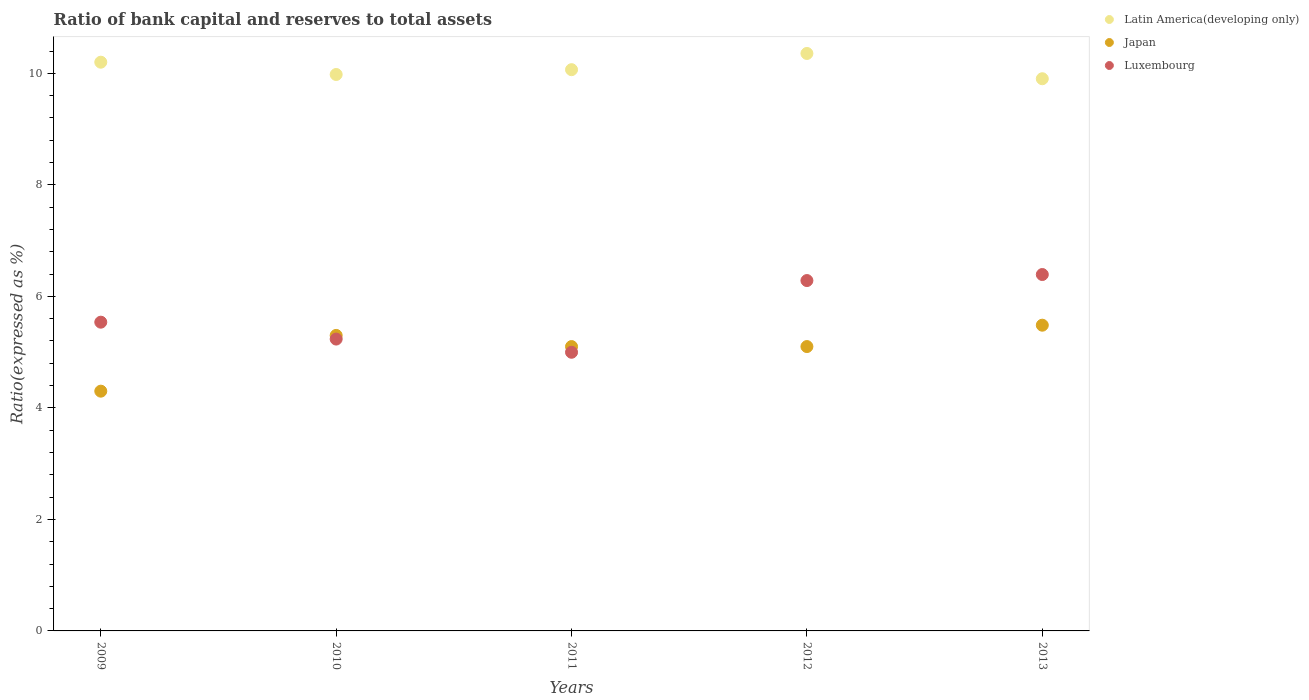What is the ratio of bank capital and reserves to total assets in Latin America(developing only) in 2012?
Offer a very short reply. 10.36. Across all years, what is the maximum ratio of bank capital and reserves to total assets in Japan?
Offer a very short reply. 5.48. Across all years, what is the minimum ratio of bank capital and reserves to total assets in Latin America(developing only)?
Offer a very short reply. 9.9. In which year was the ratio of bank capital and reserves to total assets in Latin America(developing only) maximum?
Provide a short and direct response. 2012. What is the total ratio of bank capital and reserves to total assets in Latin America(developing only) in the graph?
Give a very brief answer. 50.51. What is the difference between the ratio of bank capital and reserves to total assets in Latin America(developing only) in 2011 and that in 2013?
Make the answer very short. 0.16. What is the difference between the ratio of bank capital and reserves to total assets in Latin America(developing only) in 2010 and the ratio of bank capital and reserves to total assets in Luxembourg in 2009?
Your answer should be compact. 4.44. What is the average ratio of bank capital and reserves to total assets in Latin America(developing only) per year?
Keep it short and to the point. 10.1. In the year 2012, what is the difference between the ratio of bank capital and reserves to total assets in Luxembourg and ratio of bank capital and reserves to total assets in Latin America(developing only)?
Your answer should be compact. -4.07. In how many years, is the ratio of bank capital and reserves to total assets in Latin America(developing only) greater than 7.6 %?
Give a very brief answer. 5. Is the ratio of bank capital and reserves to total assets in Luxembourg in 2011 less than that in 2013?
Offer a very short reply. Yes. Is the difference between the ratio of bank capital and reserves to total assets in Luxembourg in 2009 and 2012 greater than the difference between the ratio of bank capital and reserves to total assets in Latin America(developing only) in 2009 and 2012?
Your response must be concise. No. What is the difference between the highest and the second highest ratio of bank capital and reserves to total assets in Latin America(developing only)?
Your response must be concise. 0.16. What is the difference between the highest and the lowest ratio of bank capital and reserves to total assets in Japan?
Offer a terse response. 1.18. In how many years, is the ratio of bank capital and reserves to total assets in Luxembourg greater than the average ratio of bank capital and reserves to total assets in Luxembourg taken over all years?
Keep it short and to the point. 2. Is it the case that in every year, the sum of the ratio of bank capital and reserves to total assets in Latin America(developing only) and ratio of bank capital and reserves to total assets in Japan  is greater than the ratio of bank capital and reserves to total assets in Luxembourg?
Make the answer very short. Yes. Does the ratio of bank capital and reserves to total assets in Latin America(developing only) monotonically increase over the years?
Keep it short and to the point. No. Is the ratio of bank capital and reserves to total assets in Japan strictly greater than the ratio of bank capital and reserves to total assets in Luxembourg over the years?
Your answer should be compact. No. How many dotlines are there?
Make the answer very short. 3. How many years are there in the graph?
Provide a succinct answer. 5. Are the values on the major ticks of Y-axis written in scientific E-notation?
Your response must be concise. No. Does the graph contain any zero values?
Offer a terse response. No. How are the legend labels stacked?
Offer a terse response. Vertical. What is the title of the graph?
Offer a terse response. Ratio of bank capital and reserves to total assets. What is the label or title of the Y-axis?
Your response must be concise. Ratio(expressed as %). What is the Ratio(expressed as %) in Japan in 2009?
Offer a very short reply. 4.3. What is the Ratio(expressed as %) in Luxembourg in 2009?
Provide a succinct answer. 5.54. What is the Ratio(expressed as %) in Latin America(developing only) in 2010?
Your response must be concise. 9.98. What is the Ratio(expressed as %) of Japan in 2010?
Keep it short and to the point. 5.3. What is the Ratio(expressed as %) of Luxembourg in 2010?
Provide a short and direct response. 5.23. What is the Ratio(expressed as %) in Latin America(developing only) in 2011?
Your answer should be very brief. 10.07. What is the Ratio(expressed as %) in Japan in 2011?
Your answer should be very brief. 5.1. What is the Ratio(expressed as %) in Luxembourg in 2011?
Make the answer very short. 5. What is the Ratio(expressed as %) in Latin America(developing only) in 2012?
Your answer should be very brief. 10.36. What is the Ratio(expressed as %) in Luxembourg in 2012?
Offer a very short reply. 6.28. What is the Ratio(expressed as %) of Latin America(developing only) in 2013?
Provide a succinct answer. 9.9. What is the Ratio(expressed as %) in Japan in 2013?
Your answer should be compact. 5.48. What is the Ratio(expressed as %) in Luxembourg in 2013?
Keep it short and to the point. 6.39. Across all years, what is the maximum Ratio(expressed as %) in Latin America(developing only)?
Offer a very short reply. 10.36. Across all years, what is the maximum Ratio(expressed as %) in Japan?
Provide a short and direct response. 5.48. Across all years, what is the maximum Ratio(expressed as %) of Luxembourg?
Offer a terse response. 6.39. Across all years, what is the minimum Ratio(expressed as %) of Latin America(developing only)?
Ensure brevity in your answer.  9.9. Across all years, what is the minimum Ratio(expressed as %) in Japan?
Your response must be concise. 4.3. Across all years, what is the minimum Ratio(expressed as %) in Luxembourg?
Make the answer very short. 5. What is the total Ratio(expressed as %) of Latin America(developing only) in the graph?
Your answer should be compact. 50.51. What is the total Ratio(expressed as %) of Japan in the graph?
Your answer should be very brief. 25.28. What is the total Ratio(expressed as %) in Luxembourg in the graph?
Offer a terse response. 28.45. What is the difference between the Ratio(expressed as %) in Latin America(developing only) in 2009 and that in 2010?
Provide a succinct answer. 0.22. What is the difference between the Ratio(expressed as %) in Japan in 2009 and that in 2010?
Offer a terse response. -1. What is the difference between the Ratio(expressed as %) of Luxembourg in 2009 and that in 2010?
Your answer should be compact. 0.3. What is the difference between the Ratio(expressed as %) of Latin America(developing only) in 2009 and that in 2011?
Your response must be concise. 0.13. What is the difference between the Ratio(expressed as %) of Japan in 2009 and that in 2011?
Offer a very short reply. -0.8. What is the difference between the Ratio(expressed as %) in Luxembourg in 2009 and that in 2011?
Offer a terse response. 0.54. What is the difference between the Ratio(expressed as %) in Latin America(developing only) in 2009 and that in 2012?
Your answer should be very brief. -0.16. What is the difference between the Ratio(expressed as %) of Japan in 2009 and that in 2012?
Provide a succinct answer. -0.8. What is the difference between the Ratio(expressed as %) of Luxembourg in 2009 and that in 2012?
Keep it short and to the point. -0.75. What is the difference between the Ratio(expressed as %) of Latin America(developing only) in 2009 and that in 2013?
Provide a short and direct response. 0.3. What is the difference between the Ratio(expressed as %) of Japan in 2009 and that in 2013?
Keep it short and to the point. -1.18. What is the difference between the Ratio(expressed as %) of Luxembourg in 2009 and that in 2013?
Keep it short and to the point. -0.85. What is the difference between the Ratio(expressed as %) of Latin America(developing only) in 2010 and that in 2011?
Keep it short and to the point. -0.09. What is the difference between the Ratio(expressed as %) of Luxembourg in 2010 and that in 2011?
Offer a terse response. 0.24. What is the difference between the Ratio(expressed as %) of Latin America(developing only) in 2010 and that in 2012?
Your response must be concise. -0.38. What is the difference between the Ratio(expressed as %) in Luxembourg in 2010 and that in 2012?
Keep it short and to the point. -1.05. What is the difference between the Ratio(expressed as %) in Latin America(developing only) in 2010 and that in 2013?
Give a very brief answer. 0.08. What is the difference between the Ratio(expressed as %) in Japan in 2010 and that in 2013?
Make the answer very short. -0.18. What is the difference between the Ratio(expressed as %) of Luxembourg in 2010 and that in 2013?
Provide a short and direct response. -1.16. What is the difference between the Ratio(expressed as %) in Latin America(developing only) in 2011 and that in 2012?
Your answer should be compact. -0.29. What is the difference between the Ratio(expressed as %) in Luxembourg in 2011 and that in 2012?
Ensure brevity in your answer.  -1.29. What is the difference between the Ratio(expressed as %) in Latin America(developing only) in 2011 and that in 2013?
Provide a short and direct response. 0.16. What is the difference between the Ratio(expressed as %) of Japan in 2011 and that in 2013?
Your answer should be very brief. -0.38. What is the difference between the Ratio(expressed as %) of Luxembourg in 2011 and that in 2013?
Make the answer very short. -1.39. What is the difference between the Ratio(expressed as %) in Latin America(developing only) in 2012 and that in 2013?
Give a very brief answer. 0.45. What is the difference between the Ratio(expressed as %) in Japan in 2012 and that in 2013?
Offer a terse response. -0.38. What is the difference between the Ratio(expressed as %) of Luxembourg in 2012 and that in 2013?
Your response must be concise. -0.11. What is the difference between the Ratio(expressed as %) of Latin America(developing only) in 2009 and the Ratio(expressed as %) of Luxembourg in 2010?
Give a very brief answer. 4.97. What is the difference between the Ratio(expressed as %) of Japan in 2009 and the Ratio(expressed as %) of Luxembourg in 2010?
Offer a very short reply. -0.93. What is the difference between the Ratio(expressed as %) of Latin America(developing only) in 2009 and the Ratio(expressed as %) of Luxembourg in 2011?
Ensure brevity in your answer.  5.2. What is the difference between the Ratio(expressed as %) in Japan in 2009 and the Ratio(expressed as %) in Luxembourg in 2011?
Offer a very short reply. -0.7. What is the difference between the Ratio(expressed as %) of Latin America(developing only) in 2009 and the Ratio(expressed as %) of Japan in 2012?
Give a very brief answer. 5.1. What is the difference between the Ratio(expressed as %) in Latin America(developing only) in 2009 and the Ratio(expressed as %) in Luxembourg in 2012?
Your response must be concise. 3.92. What is the difference between the Ratio(expressed as %) of Japan in 2009 and the Ratio(expressed as %) of Luxembourg in 2012?
Ensure brevity in your answer.  -1.98. What is the difference between the Ratio(expressed as %) of Latin America(developing only) in 2009 and the Ratio(expressed as %) of Japan in 2013?
Ensure brevity in your answer.  4.72. What is the difference between the Ratio(expressed as %) of Latin America(developing only) in 2009 and the Ratio(expressed as %) of Luxembourg in 2013?
Ensure brevity in your answer.  3.81. What is the difference between the Ratio(expressed as %) of Japan in 2009 and the Ratio(expressed as %) of Luxembourg in 2013?
Your response must be concise. -2.09. What is the difference between the Ratio(expressed as %) of Latin America(developing only) in 2010 and the Ratio(expressed as %) of Japan in 2011?
Your response must be concise. 4.88. What is the difference between the Ratio(expressed as %) in Latin America(developing only) in 2010 and the Ratio(expressed as %) in Luxembourg in 2011?
Your response must be concise. 4.98. What is the difference between the Ratio(expressed as %) in Japan in 2010 and the Ratio(expressed as %) in Luxembourg in 2011?
Give a very brief answer. 0.3. What is the difference between the Ratio(expressed as %) in Latin America(developing only) in 2010 and the Ratio(expressed as %) in Japan in 2012?
Ensure brevity in your answer.  4.88. What is the difference between the Ratio(expressed as %) of Latin America(developing only) in 2010 and the Ratio(expressed as %) of Luxembourg in 2012?
Make the answer very short. 3.7. What is the difference between the Ratio(expressed as %) of Japan in 2010 and the Ratio(expressed as %) of Luxembourg in 2012?
Provide a succinct answer. -0.98. What is the difference between the Ratio(expressed as %) of Latin America(developing only) in 2010 and the Ratio(expressed as %) of Japan in 2013?
Give a very brief answer. 4.5. What is the difference between the Ratio(expressed as %) in Latin America(developing only) in 2010 and the Ratio(expressed as %) in Luxembourg in 2013?
Ensure brevity in your answer.  3.59. What is the difference between the Ratio(expressed as %) in Japan in 2010 and the Ratio(expressed as %) in Luxembourg in 2013?
Provide a short and direct response. -1.09. What is the difference between the Ratio(expressed as %) of Latin America(developing only) in 2011 and the Ratio(expressed as %) of Japan in 2012?
Your answer should be compact. 4.97. What is the difference between the Ratio(expressed as %) of Latin America(developing only) in 2011 and the Ratio(expressed as %) of Luxembourg in 2012?
Provide a succinct answer. 3.78. What is the difference between the Ratio(expressed as %) in Japan in 2011 and the Ratio(expressed as %) in Luxembourg in 2012?
Provide a short and direct response. -1.18. What is the difference between the Ratio(expressed as %) in Latin America(developing only) in 2011 and the Ratio(expressed as %) in Japan in 2013?
Your answer should be compact. 4.58. What is the difference between the Ratio(expressed as %) in Latin America(developing only) in 2011 and the Ratio(expressed as %) in Luxembourg in 2013?
Your answer should be very brief. 3.67. What is the difference between the Ratio(expressed as %) in Japan in 2011 and the Ratio(expressed as %) in Luxembourg in 2013?
Make the answer very short. -1.29. What is the difference between the Ratio(expressed as %) in Latin America(developing only) in 2012 and the Ratio(expressed as %) in Japan in 2013?
Your response must be concise. 4.87. What is the difference between the Ratio(expressed as %) of Latin America(developing only) in 2012 and the Ratio(expressed as %) of Luxembourg in 2013?
Your answer should be compact. 3.96. What is the difference between the Ratio(expressed as %) of Japan in 2012 and the Ratio(expressed as %) of Luxembourg in 2013?
Give a very brief answer. -1.29. What is the average Ratio(expressed as %) of Latin America(developing only) per year?
Your answer should be very brief. 10.1. What is the average Ratio(expressed as %) of Japan per year?
Offer a terse response. 5.06. What is the average Ratio(expressed as %) of Luxembourg per year?
Offer a very short reply. 5.69. In the year 2009, what is the difference between the Ratio(expressed as %) of Latin America(developing only) and Ratio(expressed as %) of Japan?
Provide a short and direct response. 5.9. In the year 2009, what is the difference between the Ratio(expressed as %) in Latin America(developing only) and Ratio(expressed as %) in Luxembourg?
Ensure brevity in your answer.  4.66. In the year 2009, what is the difference between the Ratio(expressed as %) of Japan and Ratio(expressed as %) of Luxembourg?
Offer a terse response. -1.24. In the year 2010, what is the difference between the Ratio(expressed as %) in Latin America(developing only) and Ratio(expressed as %) in Japan?
Keep it short and to the point. 4.68. In the year 2010, what is the difference between the Ratio(expressed as %) in Latin America(developing only) and Ratio(expressed as %) in Luxembourg?
Your answer should be very brief. 4.75. In the year 2010, what is the difference between the Ratio(expressed as %) of Japan and Ratio(expressed as %) of Luxembourg?
Your response must be concise. 0.07. In the year 2011, what is the difference between the Ratio(expressed as %) in Latin America(developing only) and Ratio(expressed as %) in Japan?
Ensure brevity in your answer.  4.97. In the year 2011, what is the difference between the Ratio(expressed as %) of Latin America(developing only) and Ratio(expressed as %) of Luxembourg?
Offer a very short reply. 5.07. In the year 2011, what is the difference between the Ratio(expressed as %) of Japan and Ratio(expressed as %) of Luxembourg?
Keep it short and to the point. 0.1. In the year 2012, what is the difference between the Ratio(expressed as %) in Latin America(developing only) and Ratio(expressed as %) in Japan?
Your answer should be very brief. 5.26. In the year 2012, what is the difference between the Ratio(expressed as %) in Latin America(developing only) and Ratio(expressed as %) in Luxembourg?
Give a very brief answer. 4.07. In the year 2012, what is the difference between the Ratio(expressed as %) of Japan and Ratio(expressed as %) of Luxembourg?
Offer a terse response. -1.18. In the year 2013, what is the difference between the Ratio(expressed as %) of Latin America(developing only) and Ratio(expressed as %) of Japan?
Offer a very short reply. 4.42. In the year 2013, what is the difference between the Ratio(expressed as %) in Latin America(developing only) and Ratio(expressed as %) in Luxembourg?
Your answer should be very brief. 3.51. In the year 2013, what is the difference between the Ratio(expressed as %) of Japan and Ratio(expressed as %) of Luxembourg?
Offer a terse response. -0.91. What is the ratio of the Ratio(expressed as %) in Latin America(developing only) in 2009 to that in 2010?
Provide a succinct answer. 1.02. What is the ratio of the Ratio(expressed as %) of Japan in 2009 to that in 2010?
Keep it short and to the point. 0.81. What is the ratio of the Ratio(expressed as %) of Luxembourg in 2009 to that in 2010?
Give a very brief answer. 1.06. What is the ratio of the Ratio(expressed as %) in Latin America(developing only) in 2009 to that in 2011?
Make the answer very short. 1.01. What is the ratio of the Ratio(expressed as %) in Japan in 2009 to that in 2011?
Your answer should be very brief. 0.84. What is the ratio of the Ratio(expressed as %) in Luxembourg in 2009 to that in 2011?
Provide a succinct answer. 1.11. What is the ratio of the Ratio(expressed as %) in Latin America(developing only) in 2009 to that in 2012?
Offer a terse response. 0.98. What is the ratio of the Ratio(expressed as %) in Japan in 2009 to that in 2012?
Your response must be concise. 0.84. What is the ratio of the Ratio(expressed as %) of Luxembourg in 2009 to that in 2012?
Make the answer very short. 0.88. What is the ratio of the Ratio(expressed as %) of Latin America(developing only) in 2009 to that in 2013?
Your answer should be compact. 1.03. What is the ratio of the Ratio(expressed as %) of Japan in 2009 to that in 2013?
Offer a terse response. 0.78. What is the ratio of the Ratio(expressed as %) in Luxembourg in 2009 to that in 2013?
Provide a short and direct response. 0.87. What is the ratio of the Ratio(expressed as %) in Japan in 2010 to that in 2011?
Your answer should be very brief. 1.04. What is the ratio of the Ratio(expressed as %) of Luxembourg in 2010 to that in 2011?
Offer a terse response. 1.05. What is the ratio of the Ratio(expressed as %) in Latin America(developing only) in 2010 to that in 2012?
Keep it short and to the point. 0.96. What is the ratio of the Ratio(expressed as %) in Japan in 2010 to that in 2012?
Ensure brevity in your answer.  1.04. What is the ratio of the Ratio(expressed as %) of Luxembourg in 2010 to that in 2012?
Make the answer very short. 0.83. What is the ratio of the Ratio(expressed as %) of Latin America(developing only) in 2010 to that in 2013?
Provide a succinct answer. 1.01. What is the ratio of the Ratio(expressed as %) of Japan in 2010 to that in 2013?
Your answer should be compact. 0.97. What is the ratio of the Ratio(expressed as %) in Luxembourg in 2010 to that in 2013?
Your answer should be compact. 0.82. What is the ratio of the Ratio(expressed as %) in Latin America(developing only) in 2011 to that in 2012?
Offer a terse response. 0.97. What is the ratio of the Ratio(expressed as %) in Japan in 2011 to that in 2012?
Your answer should be compact. 1. What is the ratio of the Ratio(expressed as %) in Luxembourg in 2011 to that in 2012?
Offer a terse response. 0.8. What is the ratio of the Ratio(expressed as %) in Latin America(developing only) in 2011 to that in 2013?
Your answer should be very brief. 1.02. What is the ratio of the Ratio(expressed as %) of Japan in 2011 to that in 2013?
Your answer should be very brief. 0.93. What is the ratio of the Ratio(expressed as %) in Luxembourg in 2011 to that in 2013?
Your answer should be very brief. 0.78. What is the ratio of the Ratio(expressed as %) of Latin America(developing only) in 2012 to that in 2013?
Provide a succinct answer. 1.05. What is the ratio of the Ratio(expressed as %) in Japan in 2012 to that in 2013?
Ensure brevity in your answer.  0.93. What is the ratio of the Ratio(expressed as %) in Luxembourg in 2012 to that in 2013?
Offer a terse response. 0.98. What is the difference between the highest and the second highest Ratio(expressed as %) of Latin America(developing only)?
Your response must be concise. 0.16. What is the difference between the highest and the second highest Ratio(expressed as %) of Japan?
Provide a short and direct response. 0.18. What is the difference between the highest and the second highest Ratio(expressed as %) of Luxembourg?
Your answer should be compact. 0.11. What is the difference between the highest and the lowest Ratio(expressed as %) of Latin America(developing only)?
Ensure brevity in your answer.  0.45. What is the difference between the highest and the lowest Ratio(expressed as %) of Japan?
Your response must be concise. 1.18. What is the difference between the highest and the lowest Ratio(expressed as %) of Luxembourg?
Offer a terse response. 1.39. 